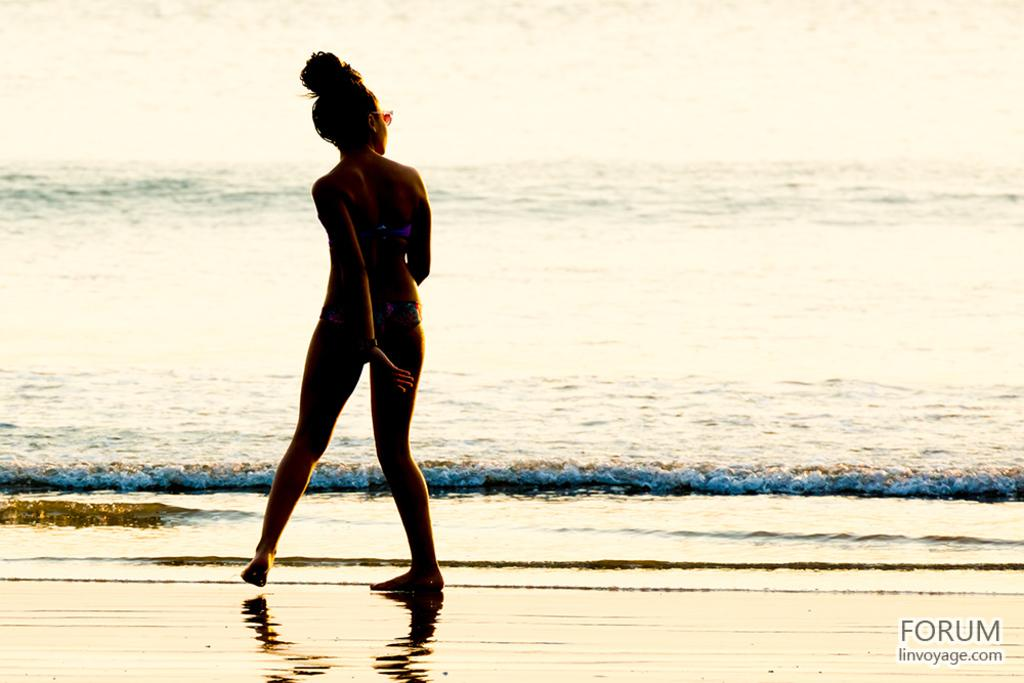What is the woman in the image doing? The woman is walking in the image. Can you describe the woman's appearance? The woman is wearing glasses. What can be seen in the background of the image? There is water visible in the image. Where is the text located in the image? The text is in the bottom right side of the image. What type of support does the woman's sister give her in the image? There is no mention of a sister in the image, so we cannot determine the type of support she might provide. 